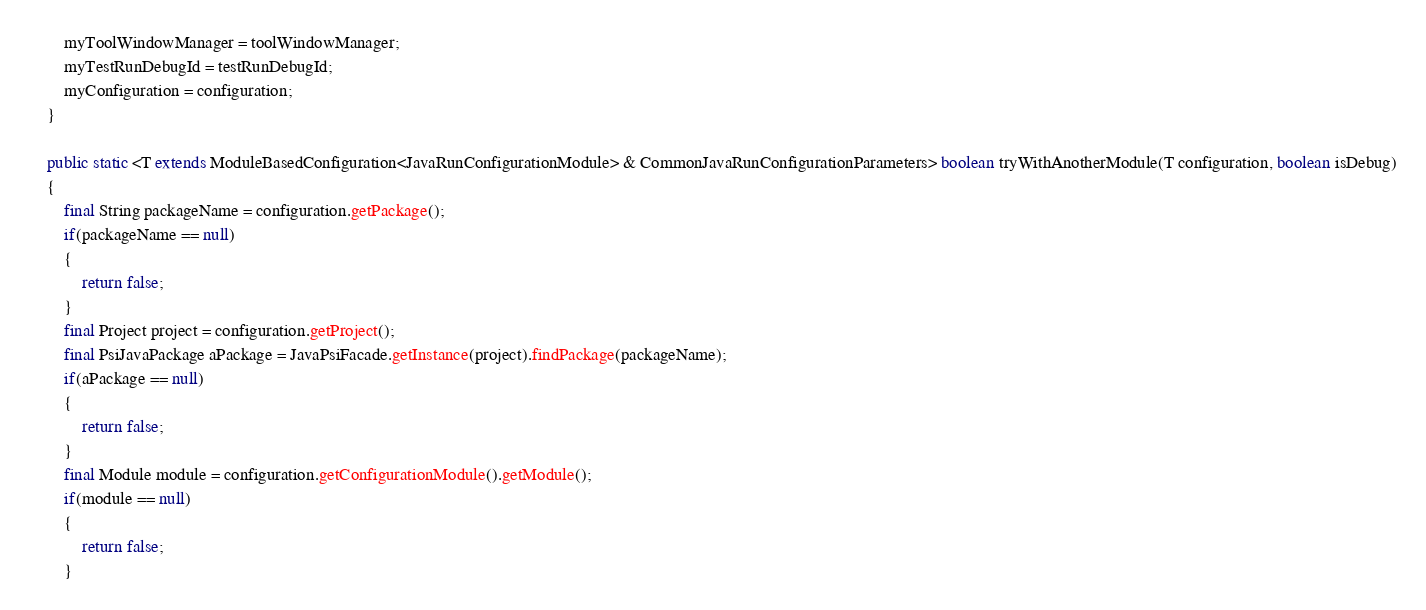Convert code to text. <code><loc_0><loc_0><loc_500><loc_500><_Java_>		myToolWindowManager = toolWindowManager;
		myTestRunDebugId = testRunDebugId;
		myConfiguration = configuration;
	}

	public static <T extends ModuleBasedConfiguration<JavaRunConfigurationModule> & CommonJavaRunConfigurationParameters> boolean tryWithAnotherModule(T configuration, boolean isDebug)
	{
		final String packageName = configuration.getPackage();
		if(packageName == null)
		{
			return false;
		}
		final Project project = configuration.getProject();
		final PsiJavaPackage aPackage = JavaPsiFacade.getInstance(project).findPackage(packageName);
		if(aPackage == null)
		{
			return false;
		}
		final Module module = configuration.getConfigurationModule().getModule();
		if(module == null)
		{
			return false;
		}</code> 